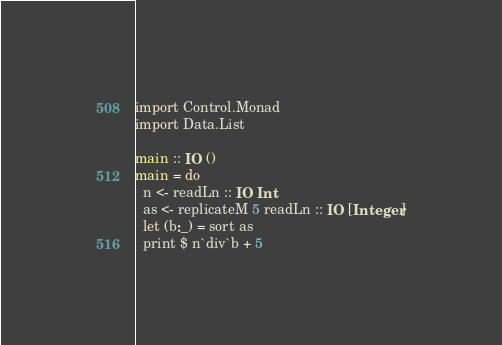Convert code to text. <code><loc_0><loc_0><loc_500><loc_500><_Haskell_>import Control.Monad
import Data.List

main :: IO ()
main = do
  n <- readLn :: IO Int
  as <- replicateM 5 readLn :: IO [Integer]
  let (b:_) = sort as
  print $ n`div`b + 5
</code> 